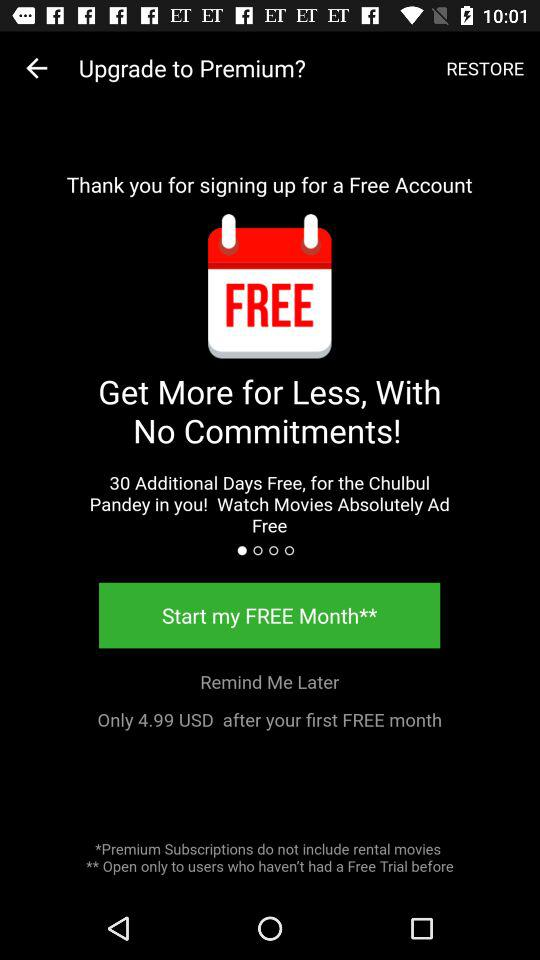How much would we pay after the first free month? You would pay 4.99 USD after the first free month. 